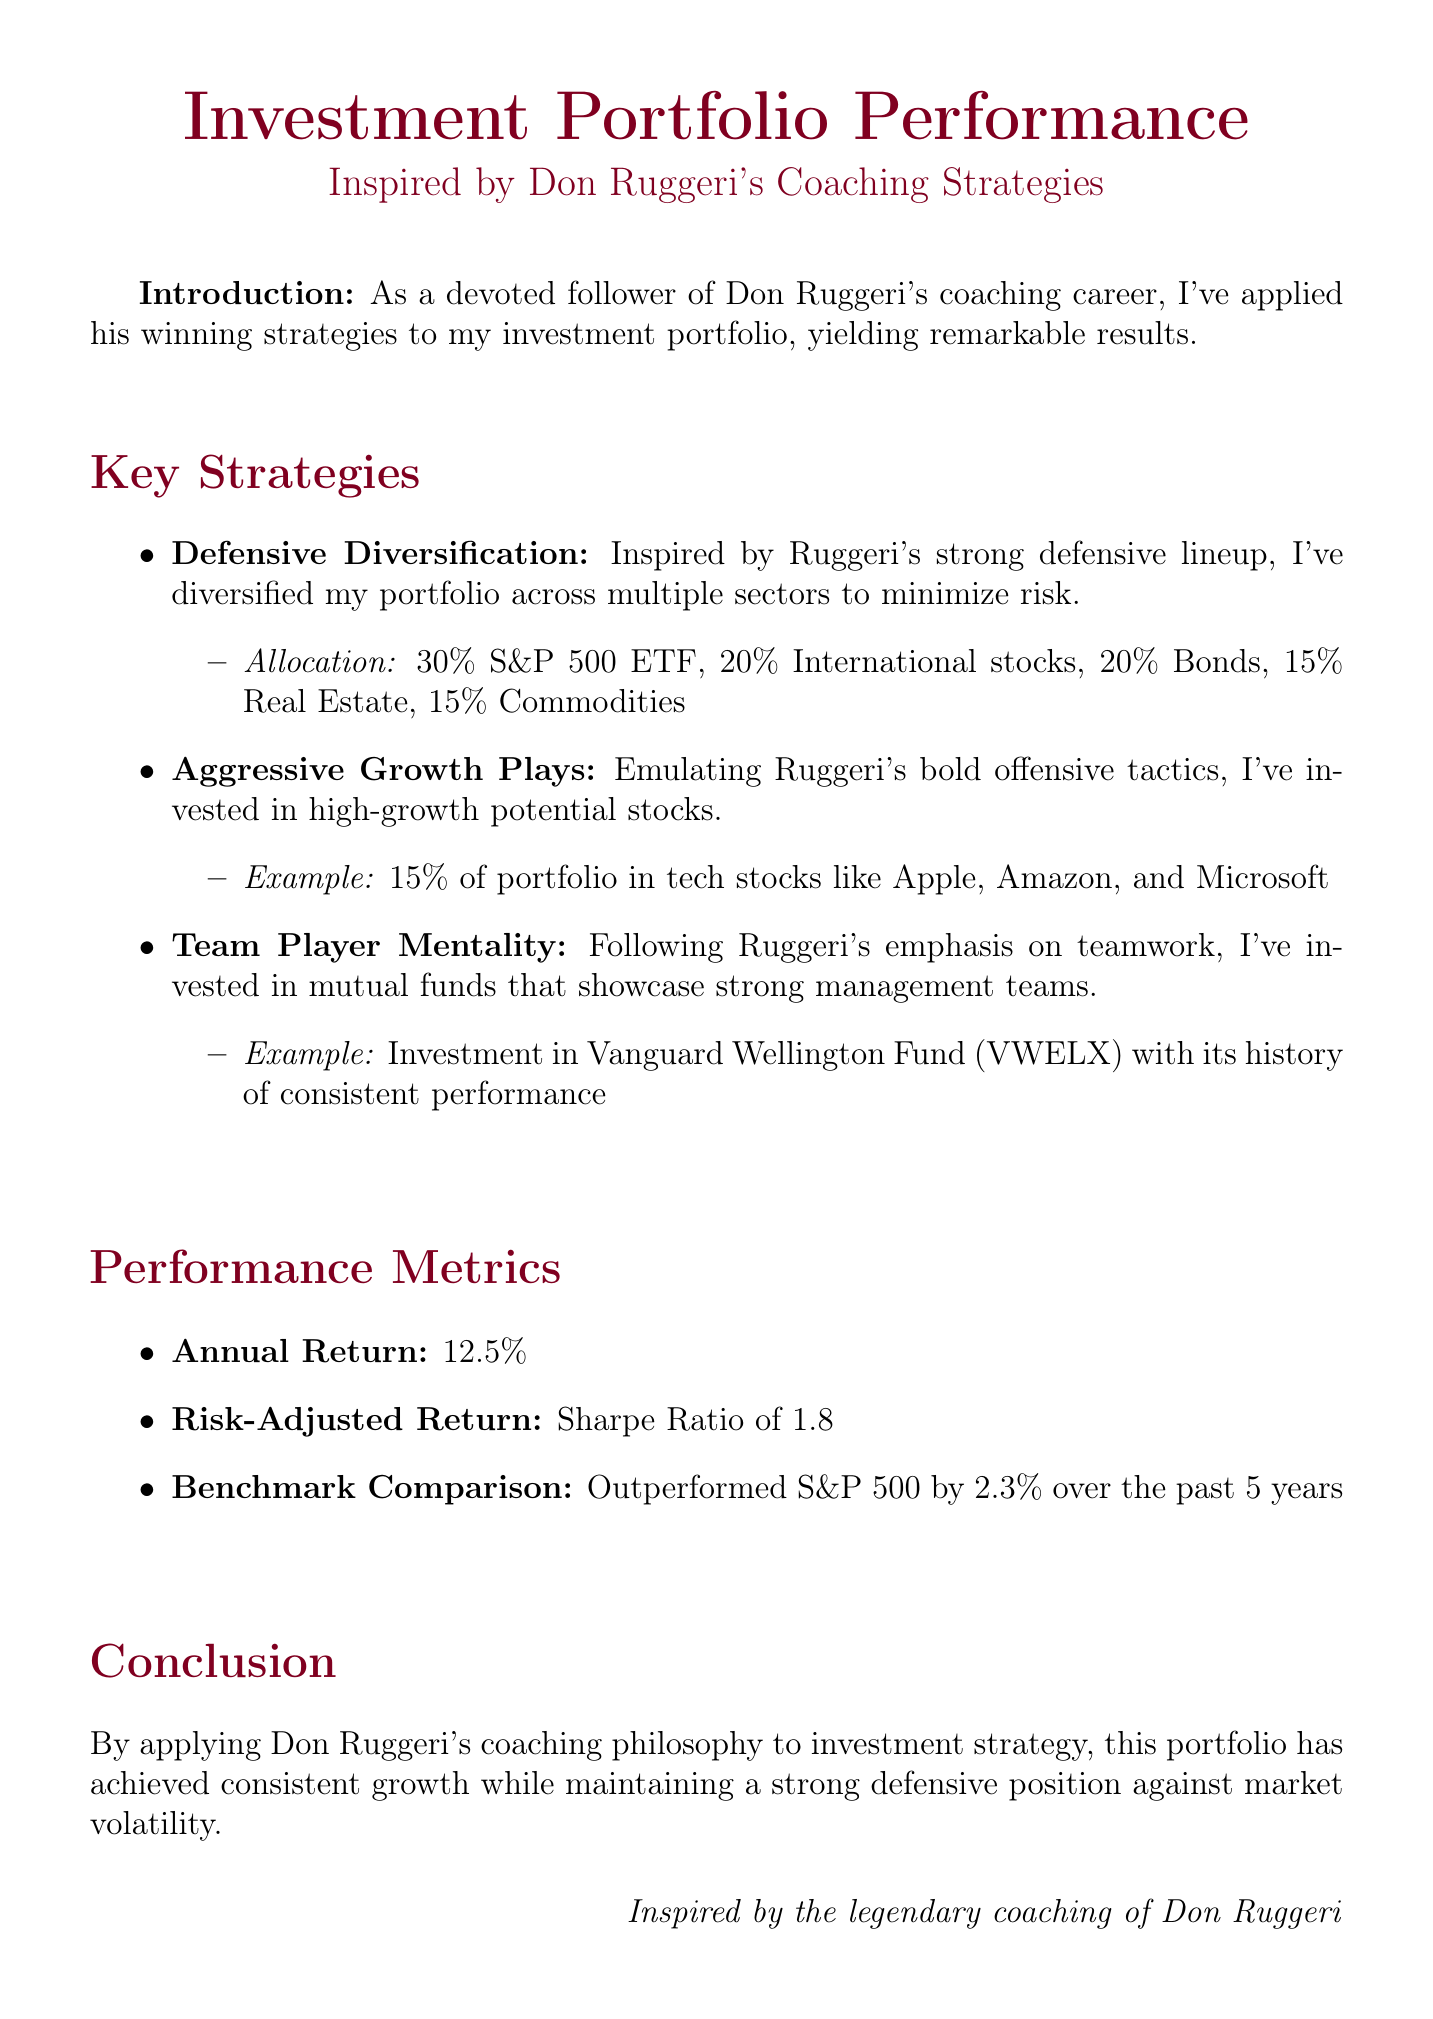What is the annual return of the portfolio? The annual return is listed in the performance metrics section of the document.
Answer: 12.5% What investment percentage is allocated to bonds? The percentage allocation to bonds is specifically mentioned in the defensive diversification strategy.
Answer: 20% Which mutual fund is mentioned as an example of a team player mentality? The mutual fund is highlighted in the key strategies section of the document.
Answer: Vanguard Wellington Fund (VWELX) What is the Sharpe Ratio of the portfolio? The Sharpe Ratio is a measure found in the performance metrics section.
Answer: 1.8 By how much did the portfolio outperform the S&P 500 over the past 5 years? This information is provided under the benchmark comparison section of the document.
Answer: 2.3% What strategy reflects Don Ruggeri's defensive lineup? The strategy specifically inspired by Ruggeri's defensive lineup is described in the key strategies section.
Answer: Defensive Diversification What is the allocation percentage for international stocks? The allocation percentage for international stocks is outlined in the defensive diversification strategy.
Answer: 20% What does the document highlight as a major theme in Don Ruggeri's coaching philosophy? The overarching theme is made clear throughout the introduction and conclusion of the report.
Answer: Teamwork 